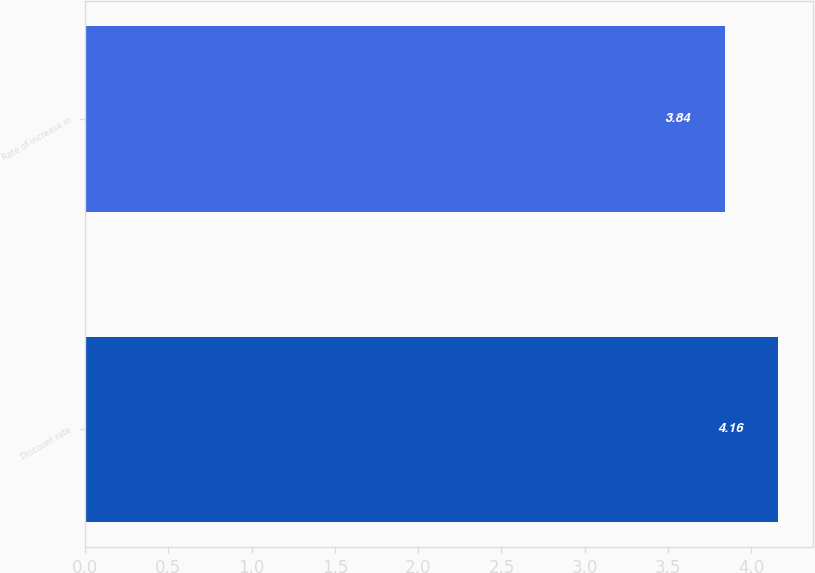Convert chart to OTSL. <chart><loc_0><loc_0><loc_500><loc_500><bar_chart><fcel>Discount rate<fcel>Rate of increase in<nl><fcel>4.16<fcel>3.84<nl></chart> 